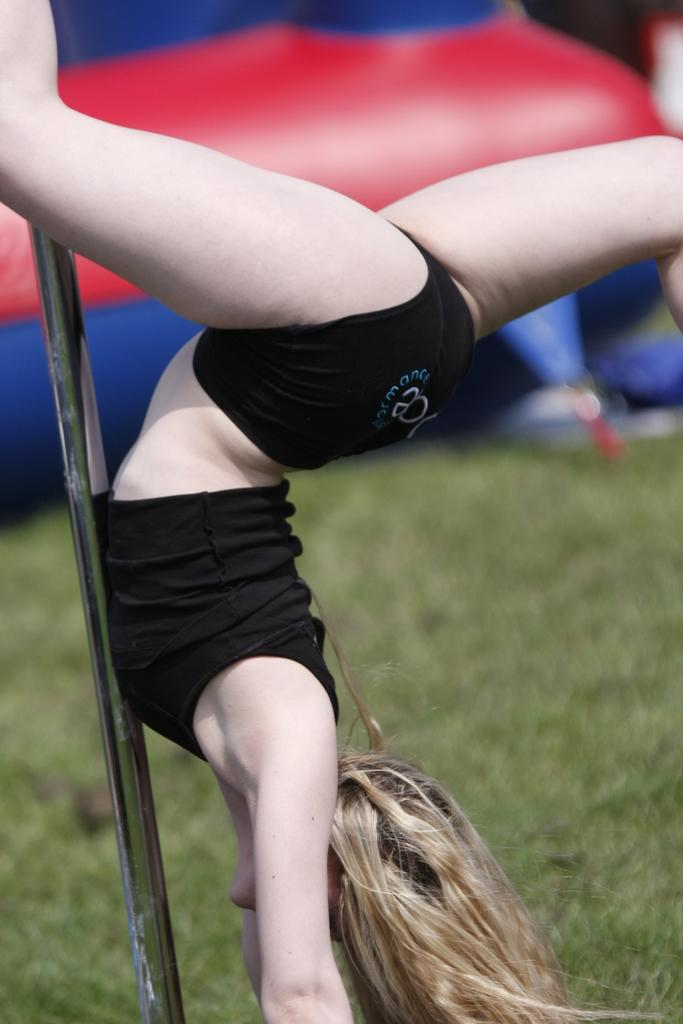What is the main object in the middle of the image? There is a pole in the middle of the image. Who is present in the image? A woman is present in the image. What is the woman doing? The woman is doing something, but we cannot determine the exact action from the facts provided. What type of natural environment is visible in the image? There is grass visible in the image. What additional object can be seen in the image? There is a balloon in the image. What type of detail can be seen on the woman's toe in the image? There is no information about the woman's toe or any details on it in the image. 